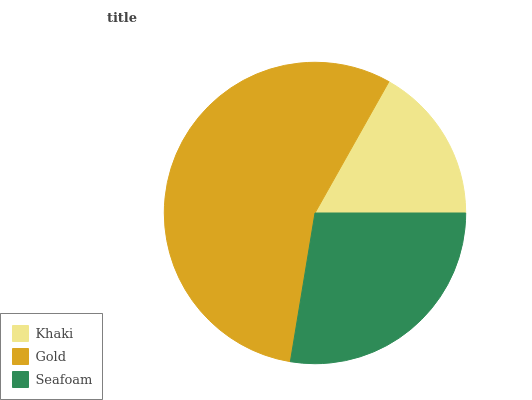Is Khaki the minimum?
Answer yes or no. Yes. Is Gold the maximum?
Answer yes or no. Yes. Is Seafoam the minimum?
Answer yes or no. No. Is Seafoam the maximum?
Answer yes or no. No. Is Gold greater than Seafoam?
Answer yes or no. Yes. Is Seafoam less than Gold?
Answer yes or no. Yes. Is Seafoam greater than Gold?
Answer yes or no. No. Is Gold less than Seafoam?
Answer yes or no. No. Is Seafoam the high median?
Answer yes or no. Yes. Is Seafoam the low median?
Answer yes or no. Yes. Is Khaki the high median?
Answer yes or no. No. Is Gold the low median?
Answer yes or no. No. 